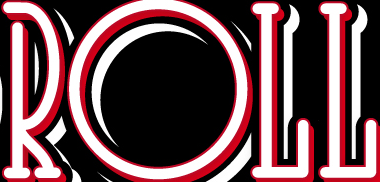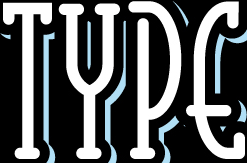What words can you see in these images in sequence, separated by a semicolon? ROLL; TYPE 